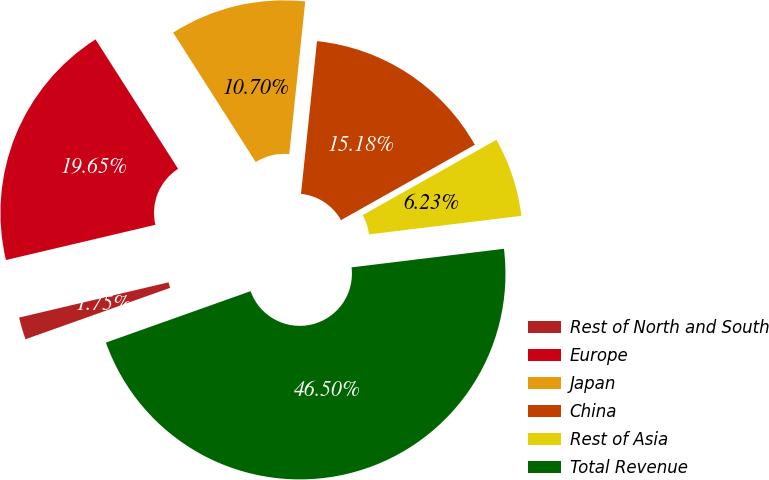Convert chart. <chart><loc_0><loc_0><loc_500><loc_500><pie_chart><fcel>Rest of North and South<fcel>Europe<fcel>Japan<fcel>China<fcel>Rest of Asia<fcel>Total Revenue<nl><fcel>1.75%<fcel>19.65%<fcel>10.7%<fcel>15.18%<fcel>6.23%<fcel>46.5%<nl></chart> 